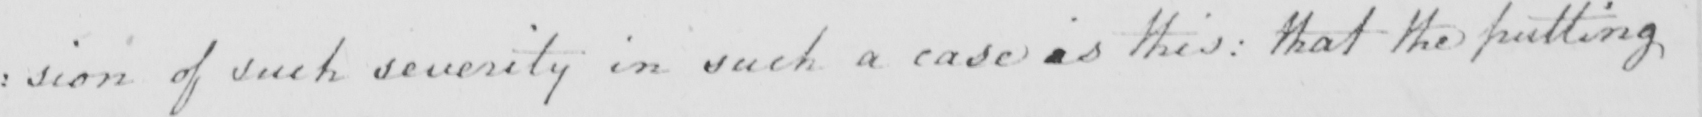What is written in this line of handwriting? : sion of such severity in such a case is this :  that the putting 